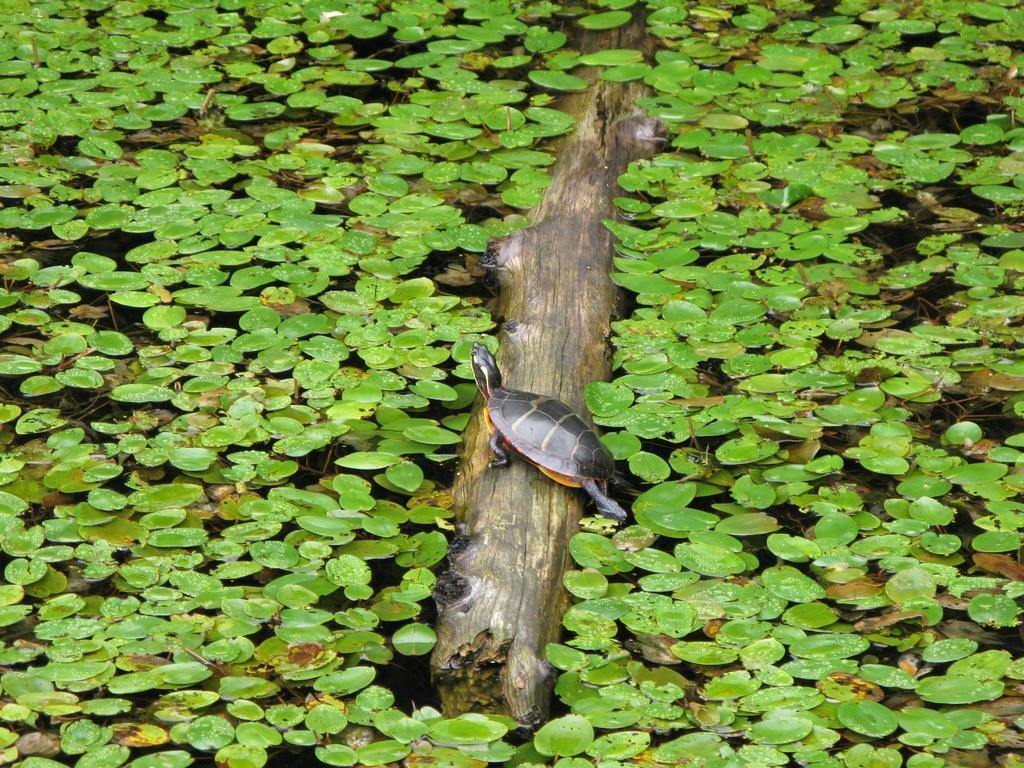Can you describe this image briefly? In the middle of the image there is a tortoise on a stem. Behind the tortoise there is water, in the water there are some plants. 